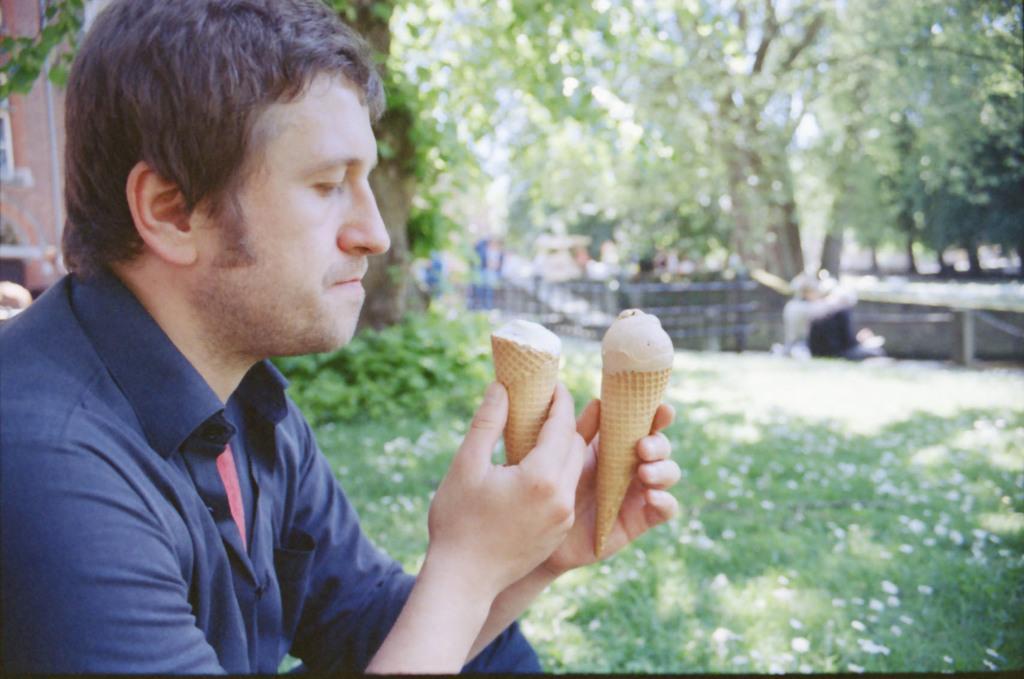Can you describe this image briefly? In this picture I can see a man sitting and holding couple of ice cream cones and I can see buildings, trees, plants and grass on the ground. 